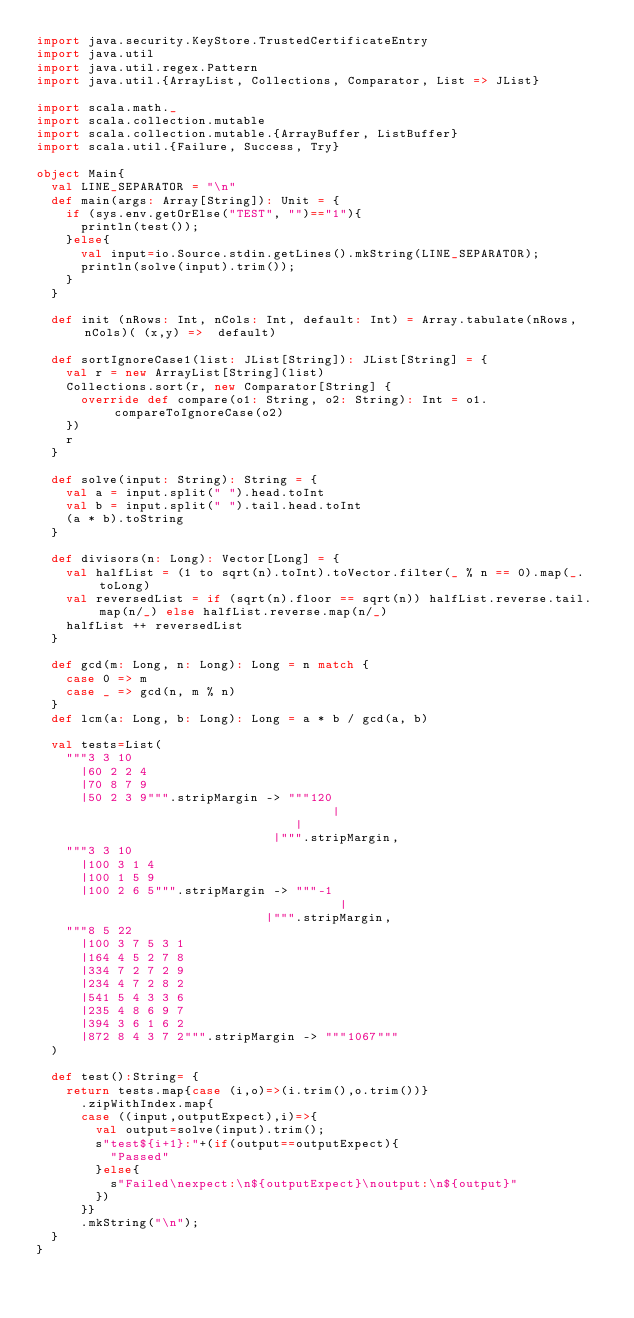Convert code to text. <code><loc_0><loc_0><loc_500><loc_500><_Scala_>import java.security.KeyStore.TrustedCertificateEntry
import java.util
import java.util.regex.Pattern
import java.util.{ArrayList, Collections, Comparator, List => JList}

import scala.math._
import scala.collection.mutable
import scala.collection.mutable.{ArrayBuffer, ListBuffer}
import scala.util.{Failure, Success, Try}

object Main{
  val LINE_SEPARATOR = "\n"
  def main(args: Array[String]): Unit = {
    if (sys.env.getOrElse("TEST", "")=="1"){
      println(test());
    }else{
      val input=io.Source.stdin.getLines().mkString(LINE_SEPARATOR);
      println(solve(input).trim());
    }
  }

  def init (nRows: Int, nCols: Int, default: Int) = Array.tabulate(nRows,nCols)( (x,y) =>  default)

  def sortIgnoreCase1(list: JList[String]): JList[String] = {
    val r = new ArrayList[String](list)
    Collections.sort(r, new Comparator[String] {
      override def compare(o1: String, o2: String): Int = o1.compareToIgnoreCase(o2)
    })
    r
  }

  def solve(input: String): String = {
    val a = input.split(" ").head.toInt
    val b = input.split(" ").tail.head.toInt
    (a * b).toString
  }

  def divisors(n: Long): Vector[Long] = {
    val halfList = (1 to sqrt(n).toInt).toVector.filter(_ % n == 0).map(_.toLong)
    val reversedList = if (sqrt(n).floor == sqrt(n)) halfList.reverse.tail.map(n/_) else halfList.reverse.map(n/_)
    halfList ++ reversedList
  }

  def gcd(m: Long, n: Long): Long = n match {
    case 0 => m
    case _ => gcd(n, m % n)
  }
  def lcm(a: Long, b: Long): Long = a * b / gcd(a, b)

  val tests=List(
    """3 3 10
      |60 2 2 4
      |70 8 7 9
      |50 2 3 9""".stripMargin -> """120
                                        |
                                   |
                                |""".stripMargin,
    """3 3 10
      |100 3 1 4
      |100 1 5 9
      |100 2 6 5""".stripMargin -> """-1
                                         |
                               |""".stripMargin,
    """8 5 22
      |100 3 7 5 3 1
      |164 4 5 2 7 8
      |334 7 2 7 2 9
      |234 4 7 2 8 2
      |541 5 4 3 3 6
      |235 4 8 6 9 7
      |394 3 6 1 6 2
      |872 8 4 3 7 2""".stripMargin -> """1067"""
  )

  def test():String= {
    return tests.map{case (i,o)=>(i.trim(),o.trim())}
      .zipWithIndex.map{
      case ((input,outputExpect),i)=>{
        val output=solve(input).trim();
        s"test${i+1}:"+(if(output==outputExpect){
          "Passed"
        }else{
          s"Failed\nexpect:\n${outputExpect}\noutput:\n${output}"
        })
      }}
      .mkString("\n");
  }
}</code> 